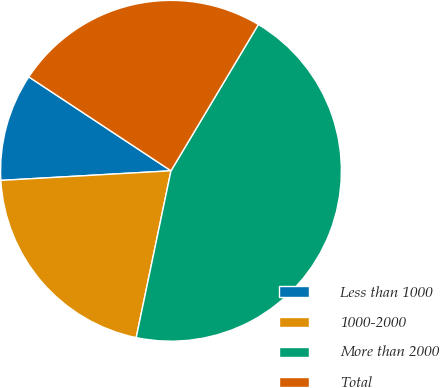Convert chart to OTSL. <chart><loc_0><loc_0><loc_500><loc_500><pie_chart><fcel>Less than 1000<fcel>1000-2000<fcel>More than 2000<fcel>Total<nl><fcel>10.19%<fcel>20.83%<fcel>44.71%<fcel>24.28%<nl></chart> 